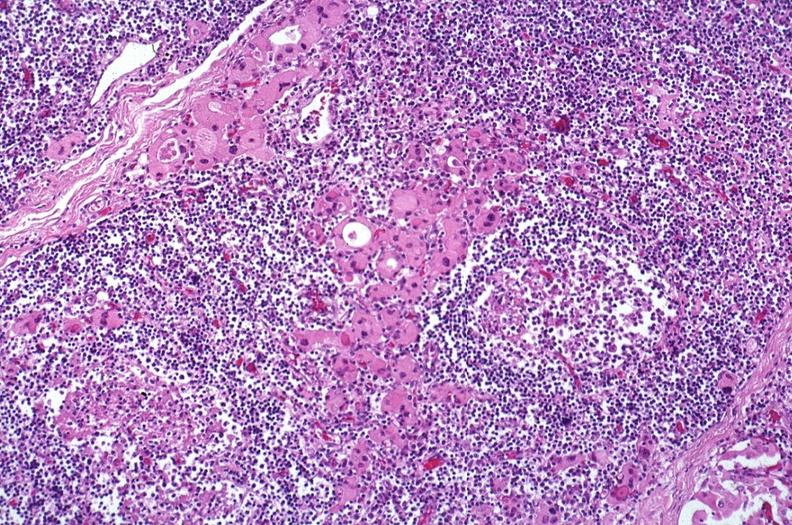where is this part in the figure?
Answer the question using a single word or phrase. Endocrine system 